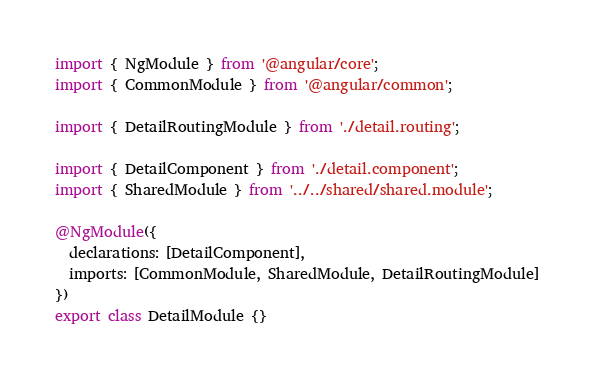<code> <loc_0><loc_0><loc_500><loc_500><_TypeScript_>import { NgModule } from '@angular/core';
import { CommonModule } from '@angular/common';

import { DetailRoutingModule } from './detail.routing';

import { DetailComponent } from './detail.component';
import { SharedModule } from '../../shared/shared.module';

@NgModule({
  declarations: [DetailComponent],
  imports: [CommonModule, SharedModule, DetailRoutingModule]
})
export class DetailModule {}
</code> 